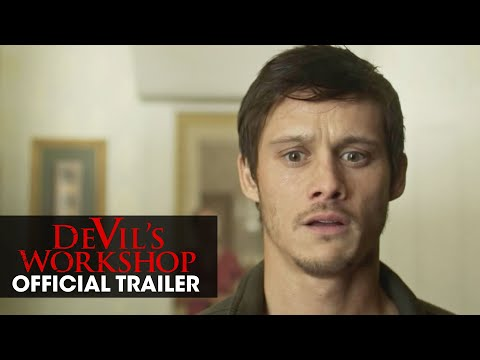Analyze the image in a comprehensive and detailed manner. The image portrays an actor, appearing in a distressed emotional state, likely capturing a pivotal moment in the thriller movie 'Devil's Workshop'. He stands against a minimalist backdrop with just a single artwork hanging, focusing viewer attention solely on his expression. His wide eyes and slightly open mouth suggest a moment of revelation or shock. The 'OFFICIAL TRAILER' text and red overlay give it a promotional context, drawing attention to its source. This stark yet emotive setup might hint at themes of surprise, fear, or confrontation that are central to the film's narrative. 